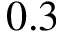<formula> <loc_0><loc_0><loc_500><loc_500>0 . 3</formula> 